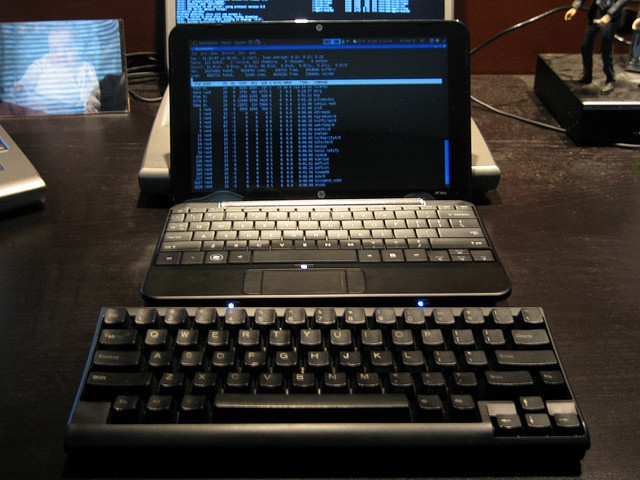Describe the objects in this image and their specific colors. I can see laptop in black, gray, and navy tones, keyboard in black, gray, and tan tones, keyboard in black, gray, and tan tones, and laptop in black, tan, and lightblue tones in this image. 